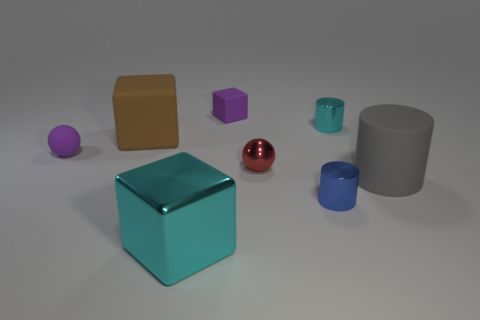Is the red thing made of the same material as the cyan thing behind the large brown block?
Provide a succinct answer. Yes. What size is the other rubber thing that is the same shape as the large brown object?
Your answer should be compact. Small. Is the number of large brown matte blocks in front of the small blue shiny cylinder the same as the number of blue objects to the left of the cyan shiny block?
Keep it short and to the point. Yes. Are there the same number of things in front of the big cylinder and tiny purple things?
Your answer should be compact. Yes. Do the red sphere and the blue metallic object in front of the small purple rubber sphere have the same size?
Make the answer very short. Yes. The cyan shiny thing that is right of the blue cylinder has what shape?
Offer a terse response. Cylinder. Is there any other thing that is the same shape as the large brown matte thing?
Provide a succinct answer. Yes. Is there a big cyan metal block?
Your answer should be very brief. Yes. There is a purple thing in front of the purple cube; is its size the same as the cyan metal object that is behind the gray cylinder?
Make the answer very short. Yes. There is a large thing that is both on the left side of the tiny red sphere and behind the blue cylinder; what is its material?
Make the answer very short. Rubber. 